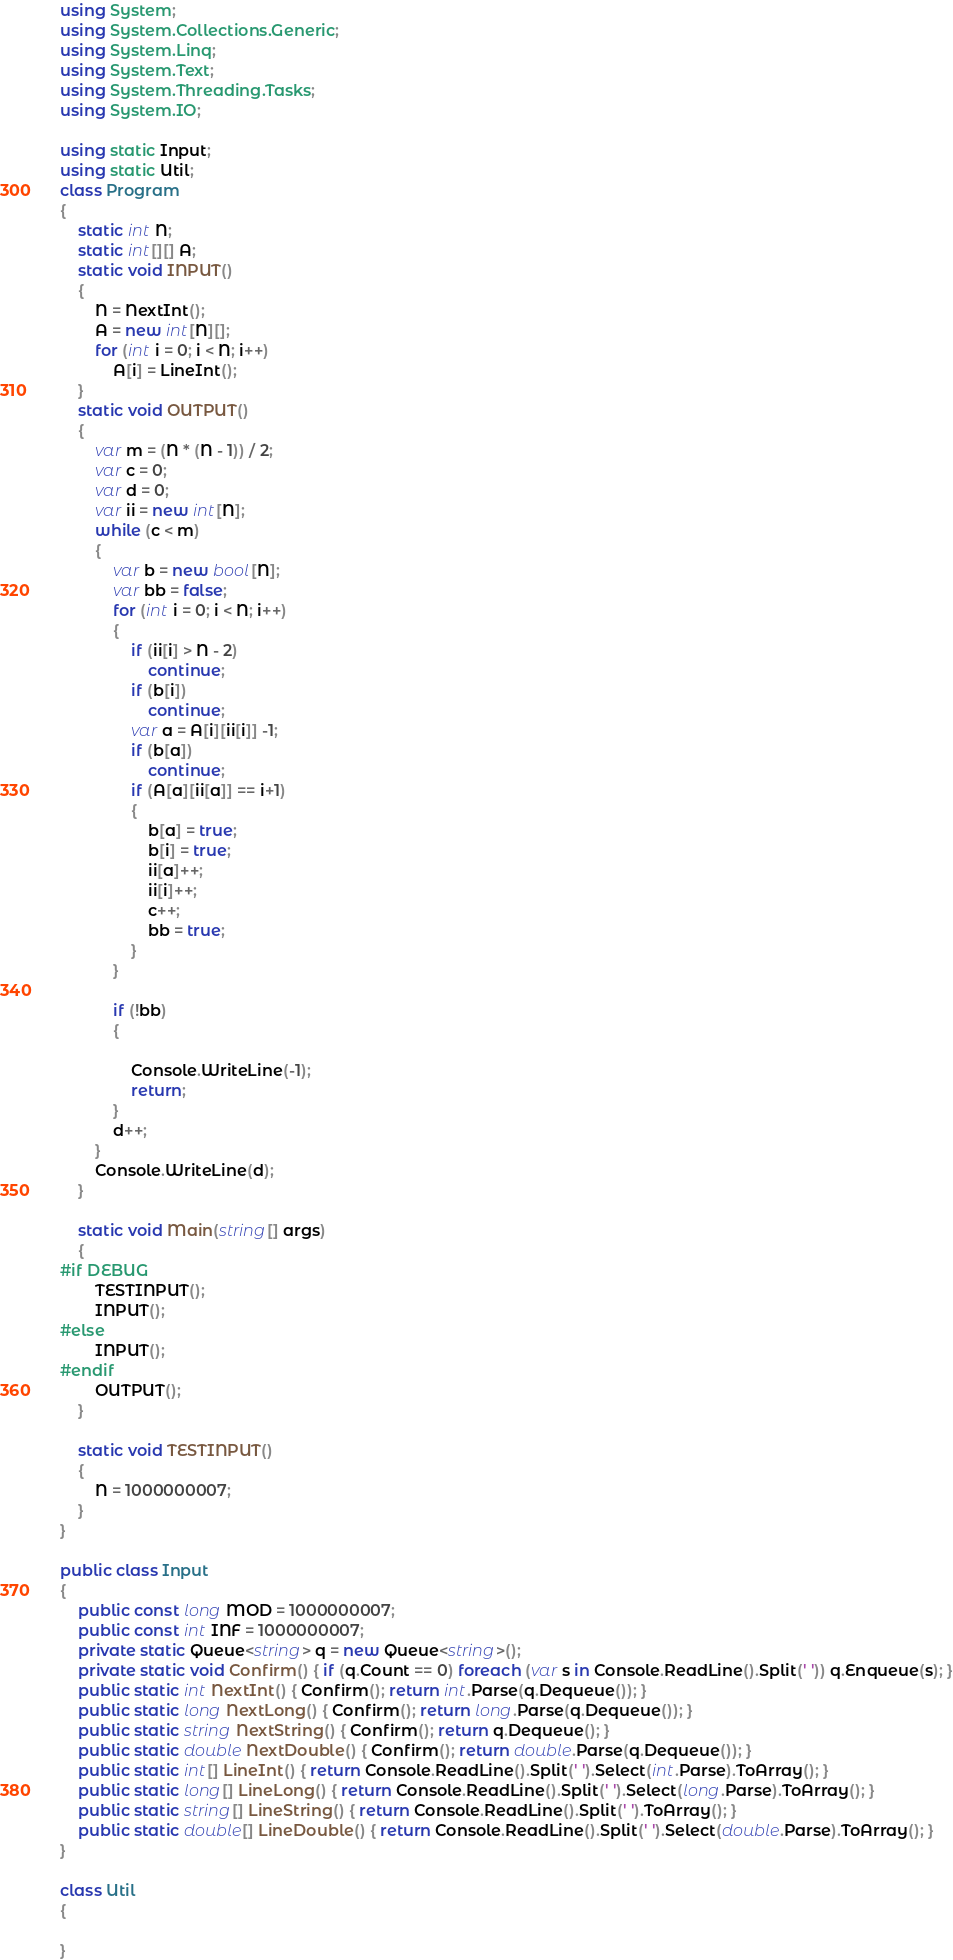Convert code to text. <code><loc_0><loc_0><loc_500><loc_500><_C#_>using System;
using System.Collections.Generic;
using System.Linq;
using System.Text;
using System.Threading.Tasks;
using System.IO;

using static Input;
using static Util;
class Program
{
    static int N;
    static int[][] A;
    static void INPUT()
    {
        N = NextInt();
        A = new int[N][];
        for (int i = 0; i < N; i++)
            A[i] = LineInt();
    }
    static void OUTPUT()
    {
        var m = (N * (N - 1)) / 2;
        var c = 0;
        var d = 0;
        var ii = new int[N];
        while (c < m)
        {
            var b = new bool[N];
            var bb = false;
            for (int i = 0; i < N; i++)
            {
                if (ii[i] > N - 2)
                    continue;
                if (b[i])
                    continue;
                var a = A[i][ii[i]] -1;
                if (b[a])
                    continue;
                if (A[a][ii[a]] == i+1)
                {
                    b[a] = true;
                    b[i] = true;
                    ii[a]++;
                    ii[i]++;
                    c++;
                    bb = true;
                }
            }

            if (!bb)
            {

                Console.WriteLine(-1);
                return;
            }
            d++;
        }
        Console.WriteLine(d);
    }

    static void Main(string[] args)
    {
#if DEBUG  
        TESTINPUT();
        INPUT();
#else
        INPUT();
#endif
        OUTPUT();
    }

    static void TESTINPUT()
    {
        N = 1000000007;
    }
}

public class Input
{
    public const long MOD = 1000000007;
    public const int INF = 1000000007;
    private static Queue<string> q = new Queue<string>();
    private static void Confirm() { if (q.Count == 0) foreach (var s in Console.ReadLine().Split(' ')) q.Enqueue(s); }
    public static int NextInt() { Confirm(); return int.Parse(q.Dequeue()); }
    public static long NextLong() { Confirm(); return long.Parse(q.Dequeue()); }
    public static string NextString() { Confirm(); return q.Dequeue(); }
    public static double NextDouble() { Confirm(); return double.Parse(q.Dequeue()); }
    public static int[] LineInt() { return Console.ReadLine().Split(' ').Select(int.Parse).ToArray(); }
    public static long[] LineLong() { return Console.ReadLine().Split(' ').Select(long.Parse).ToArray(); }
    public static string[] LineString() { return Console.ReadLine().Split(' ').ToArray(); }
    public static double[] LineDouble() { return Console.ReadLine().Split(' ').Select(double.Parse).ToArray(); }
}

class Util
{

}


</code> 